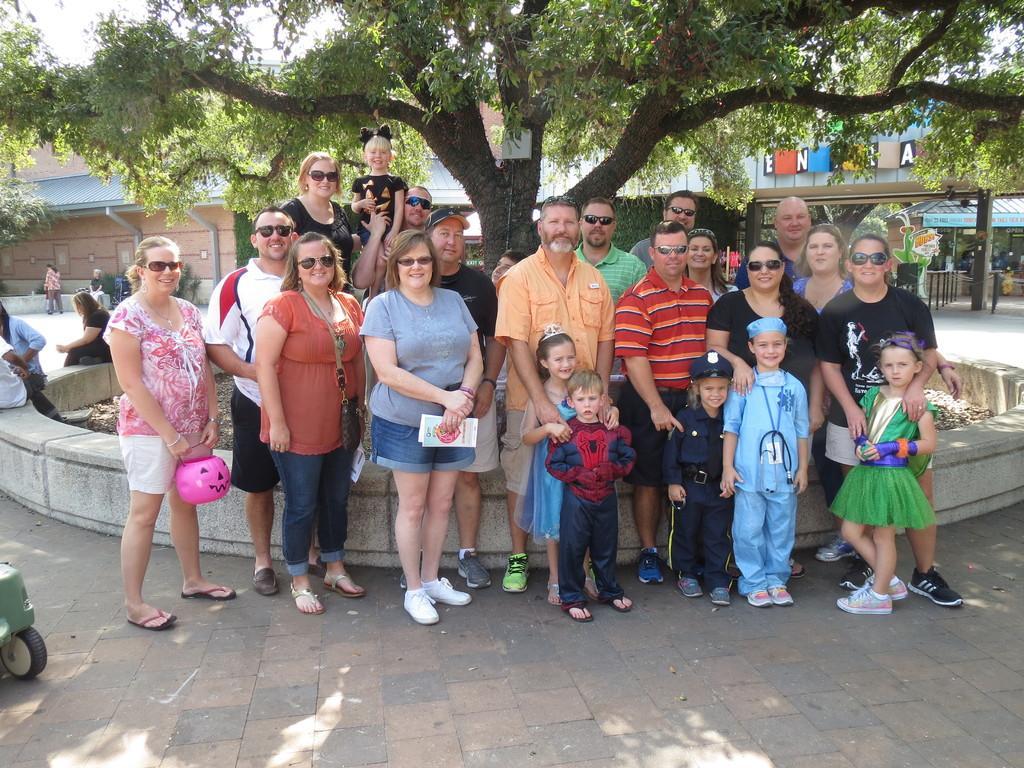How would you summarize this image in a sentence or two? In this picture there are people in the center of the image and there are other people on the left side of the image, there are stalls on the right side of the image and there is a trees and buildings at the top side of the image. 